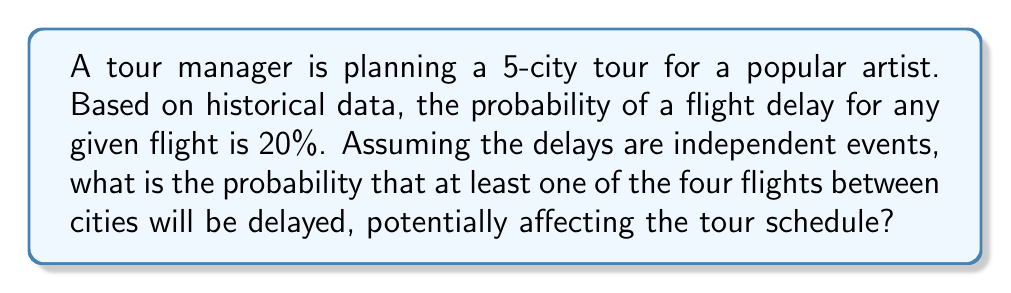Provide a solution to this math problem. Let's approach this step-by-step:

1) First, we need to find the probability that all flights are on time. 
   The probability of a single flight being on time is $1 - 0.20 = 0.80$ or $80\%$.

2) For all four flights to be on time, we multiply these probabilities:
   $P(\text{all on time}) = 0.80 \times 0.80 \times 0.80 \times 0.80 = 0.80^4$

3) We can calculate this:
   $0.80^4 = 0.4096$

4) Now, the probability of at least one flight being delayed is the complement of all flights being on time:
   $P(\text{at least one delay}) = 1 - P(\text{all on time})$

5) Substituting our calculated value:
   $P(\text{at least one delay}) = 1 - 0.4096 = 0.5904$

6) Converting to a percentage:
   $0.5904 \times 100\% = 59.04\%$

Therefore, there is a 59.04% chance that at least one of the four flights will be delayed, potentially affecting the tour schedule.
Answer: 59.04% 